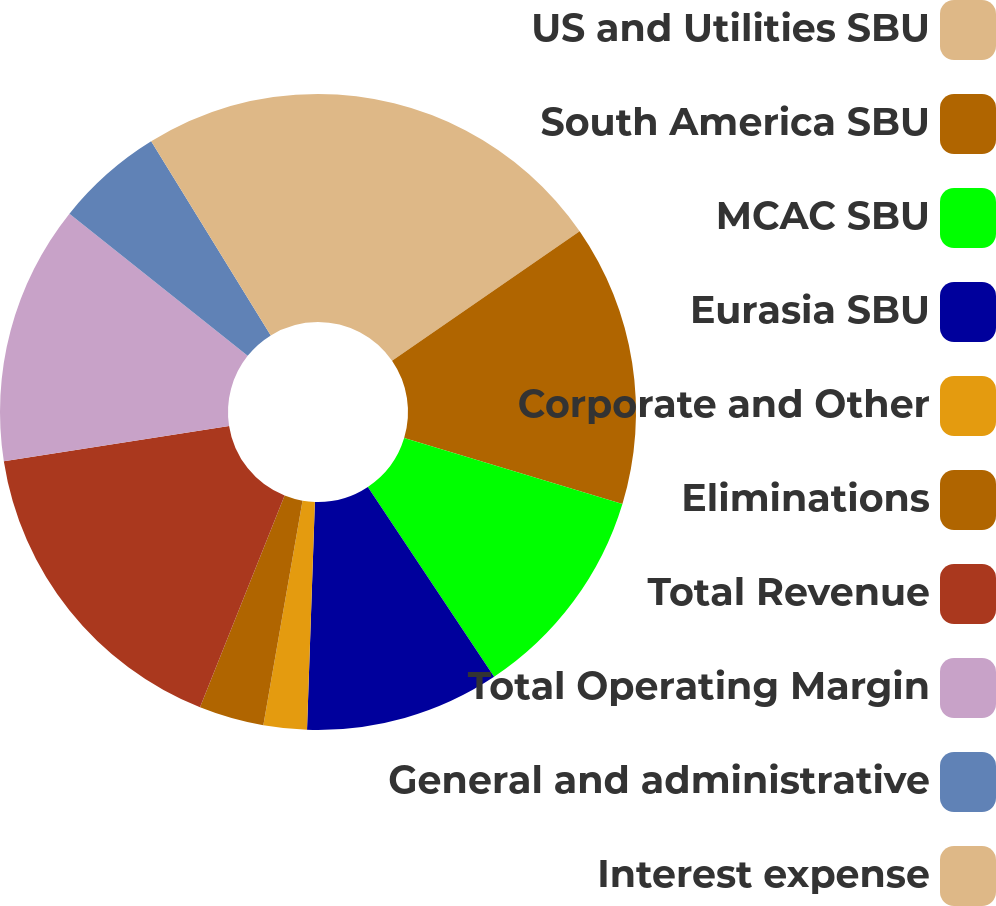<chart> <loc_0><loc_0><loc_500><loc_500><pie_chart><fcel>US and Utilities SBU<fcel>South America SBU<fcel>MCAC SBU<fcel>Eurasia SBU<fcel>Corporate and Other<fcel>Eliminations<fcel>Total Revenue<fcel>Total Operating Margin<fcel>General and administrative<fcel>Interest expense<nl><fcel>15.38%<fcel>14.29%<fcel>10.99%<fcel>9.89%<fcel>2.2%<fcel>3.3%<fcel>16.48%<fcel>13.19%<fcel>5.49%<fcel>8.79%<nl></chart> 